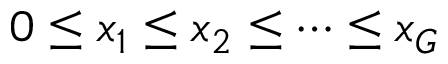Convert formula to latex. <formula><loc_0><loc_0><loc_500><loc_500>0 \leq x _ { 1 } \leq x _ { 2 } \leq \dots \leq x _ { G }</formula> 